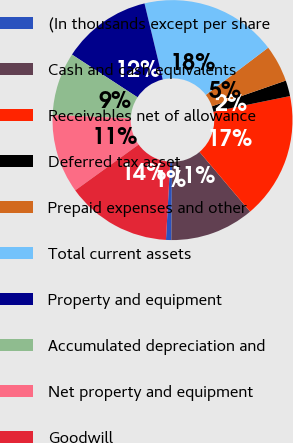<chart> <loc_0><loc_0><loc_500><loc_500><pie_chart><fcel>(In thousands except per share<fcel>Cash and cash equivalents<fcel>Receivables net of allowance<fcel>Deferred tax asset<fcel>Prepaid expenses and other<fcel>Total current assets<fcel>Property and equipment<fcel>Accumulated depreciation and<fcel>Net property and equipment<fcel>Goodwill<nl><fcel>0.71%<fcel>11.35%<fcel>17.02%<fcel>2.13%<fcel>4.97%<fcel>18.44%<fcel>12.06%<fcel>8.51%<fcel>10.64%<fcel>14.18%<nl></chart> 